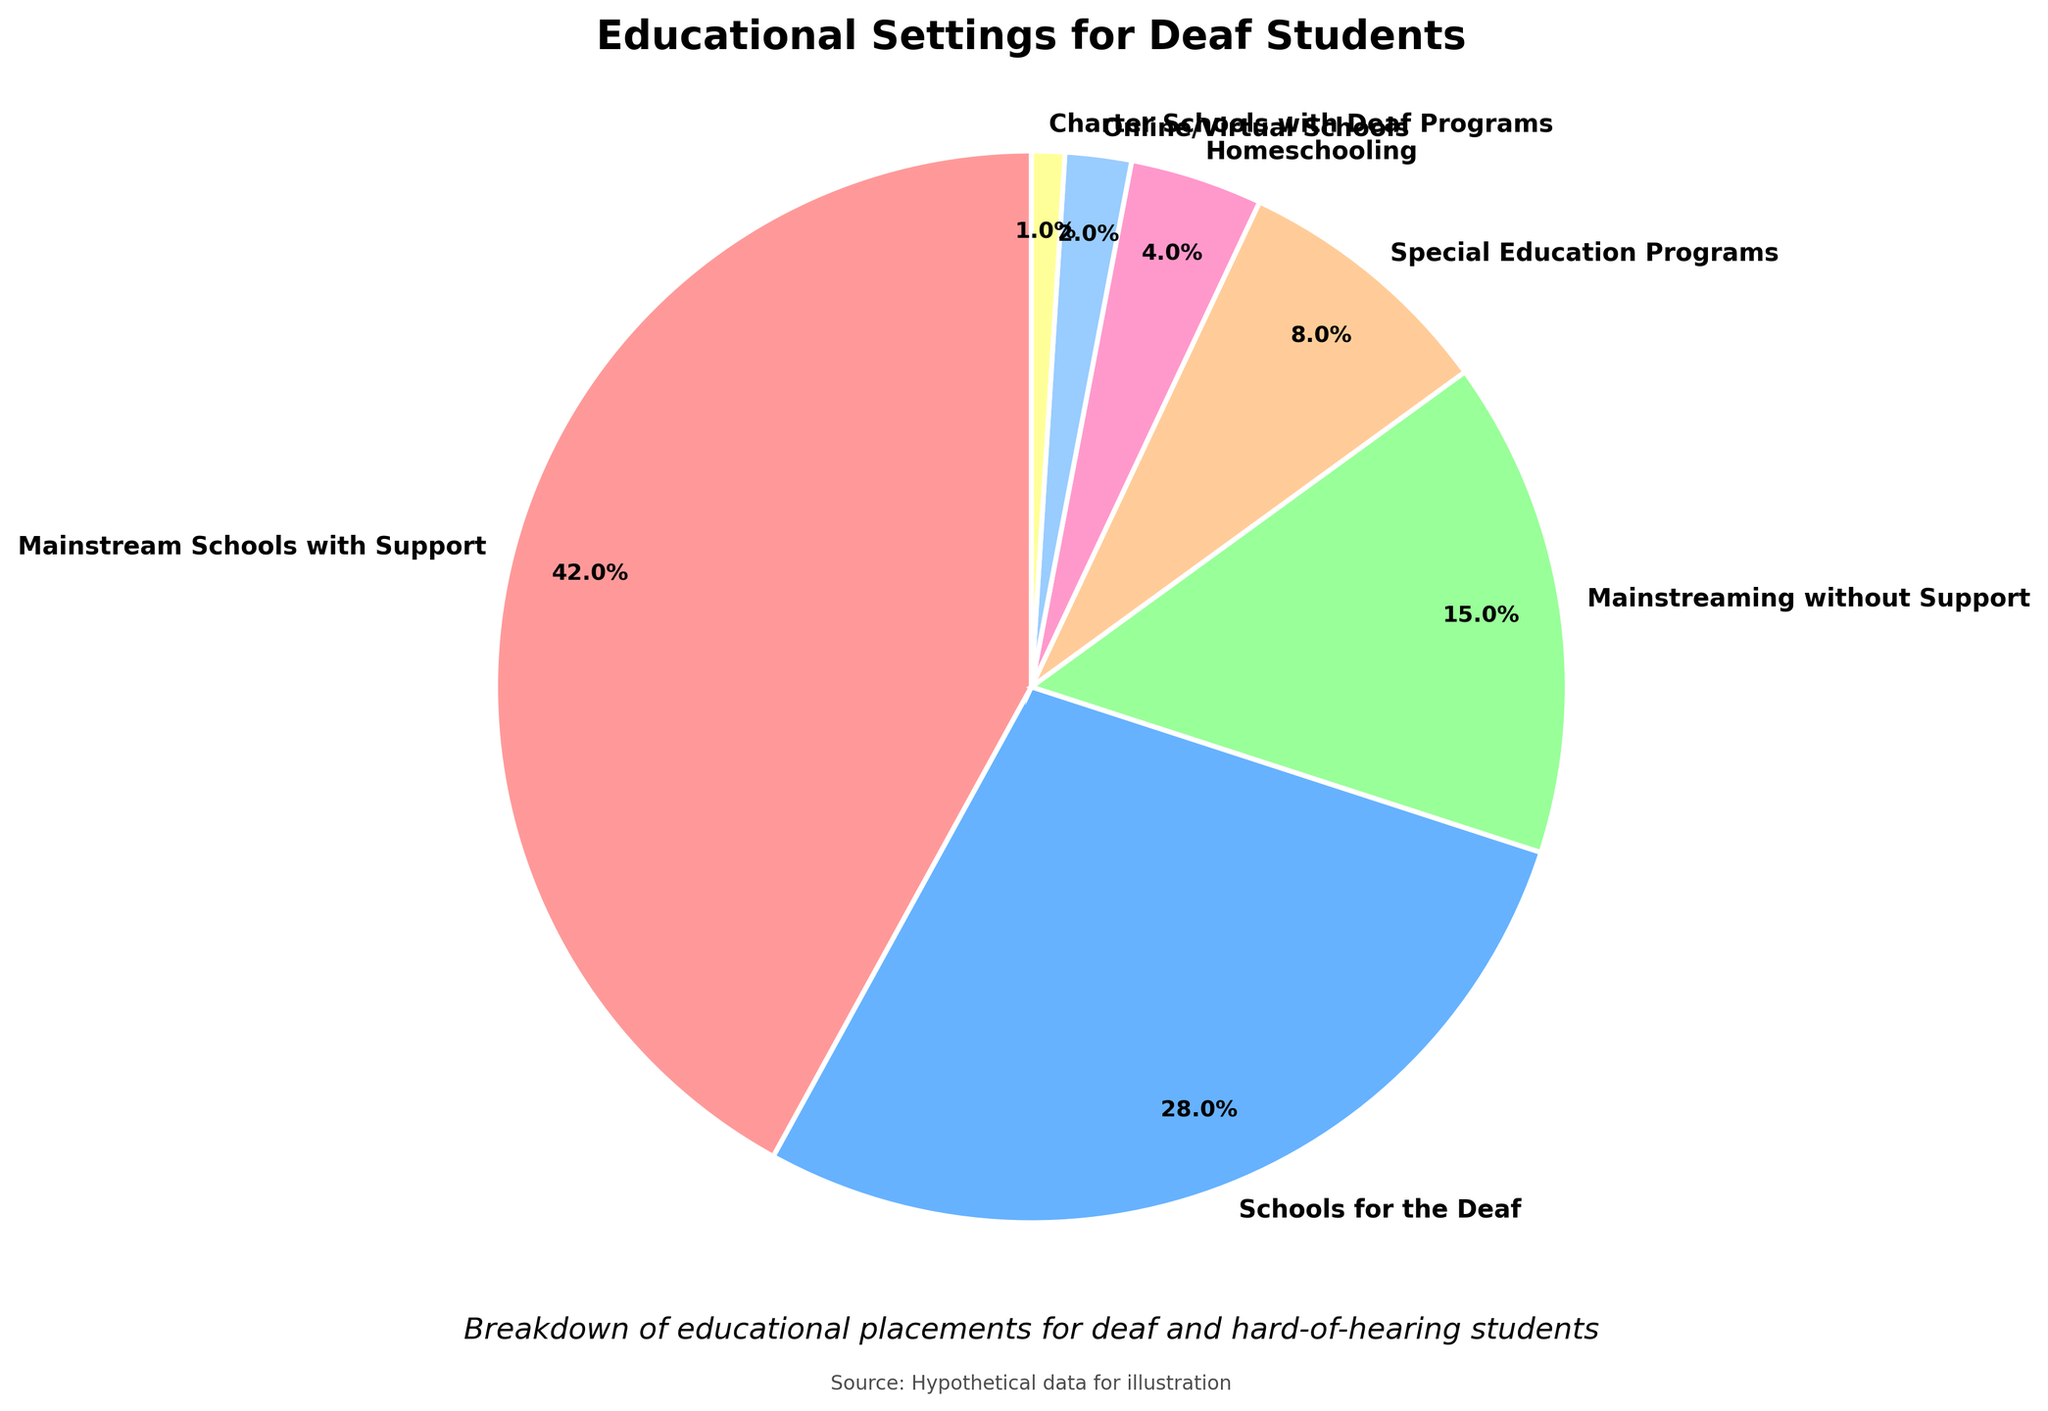Which educational setting has the largest percentage of deaf students? The pie chart shows that Mainstream Schools with Support has the largest percentage, indicated by the largest wedge.
Answer: Mainstream Schools with Support What is the combined percentage of deaf students in Special Education Programs and Homeschooling? To find the combined percentage, add the percentages of Special Education Programs and Homeschooling: 8% + 4% = 12%.
Answer: 12% How does the percentage of students in Mainstreaming without Support compare to those in Schools for the Deaf? The percentage of students in Mainstreaming without Support (15%) is less than that of Schools for the Deaf (28%).
Answer: Less What percentage of deaf students is in Online/Virtual Schools? The pie chart indicates that Online/Virtual Schools account for 2% of the deaf student population.
Answer: 2% Which educational setting has the smallest representation in the pie chart? The smallest wedge in the pie chart represents Charter Schools with Deaf Programs, which has a 1% share.
Answer: Charter Schools with Deaf Programs What is the difference in percentage between Mainstream Schools with Support and Schools for the Deaf? To find the difference, subtract the percentage of Schools for the Deaf from Mainstream Schools with Support: 42% - 28% = 14%.
Answer: 14% What is the total percentage of deaf students in mainstream settings (with and without support)? To find the total, add the percentages of Mainstream Schools with Support (42%) and Mainstreaming without Support (15%): 42% + 15% = 57%.
Answer: 57% How does the percentage of homeschooling compare to online/virtual schools? The pie chart shows that homeschooling (4%) is greater than online/virtual schools (2%).
Answer: Greater What is the combined percentage of students in specialized educational settings (Schools for the Deaf, Special Education Programs, and Charter Schools with Deaf Programs)? To find the combined percentage, add the percentages of Schools for the Deaf (28%), Special Education Programs (8%), and Charter Schools with Deaf Programs (1%): 28% + 8% + 1% = 37%.
Answer: 37% Which color represents Schools for the Deaf, and how much of the total chart does it occupy? The color blue represents Schools for the Deaf, which occupies 28% of the total chart.
Answer: Blue, 28% 